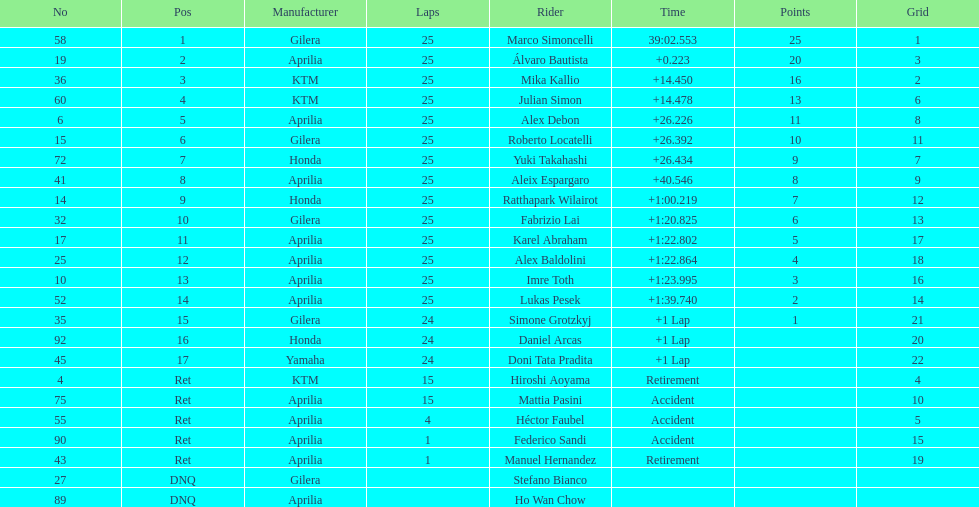The country with the most riders was Italy. 